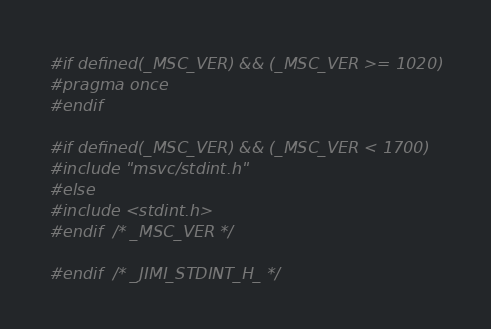Convert code to text. <code><loc_0><loc_0><loc_500><loc_500><_C_>
#if defined(_MSC_VER) && (_MSC_VER >= 1020)
#pragma once
#endif

#if defined(_MSC_VER) && (_MSC_VER < 1700)
#include "msvc/stdint.h"
#else
#include <stdint.h>
#endif  /* _MSC_VER */

#endif  /* _JIMI_STDINT_H_ */
</code> 